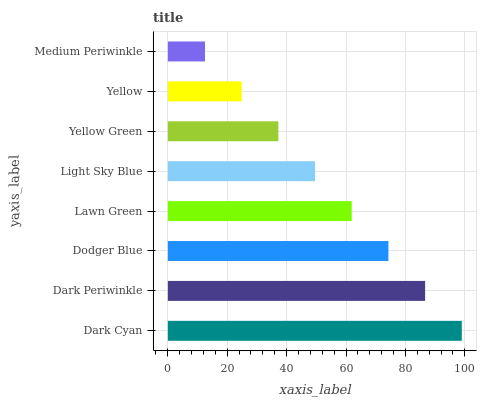Is Medium Periwinkle the minimum?
Answer yes or no. Yes. Is Dark Cyan the maximum?
Answer yes or no. Yes. Is Dark Periwinkle the minimum?
Answer yes or no. No. Is Dark Periwinkle the maximum?
Answer yes or no. No. Is Dark Cyan greater than Dark Periwinkle?
Answer yes or no. Yes. Is Dark Periwinkle less than Dark Cyan?
Answer yes or no. Yes. Is Dark Periwinkle greater than Dark Cyan?
Answer yes or no. No. Is Dark Cyan less than Dark Periwinkle?
Answer yes or no. No. Is Lawn Green the high median?
Answer yes or no. Yes. Is Light Sky Blue the low median?
Answer yes or no. Yes. Is Dark Cyan the high median?
Answer yes or no. No. Is Medium Periwinkle the low median?
Answer yes or no. No. 